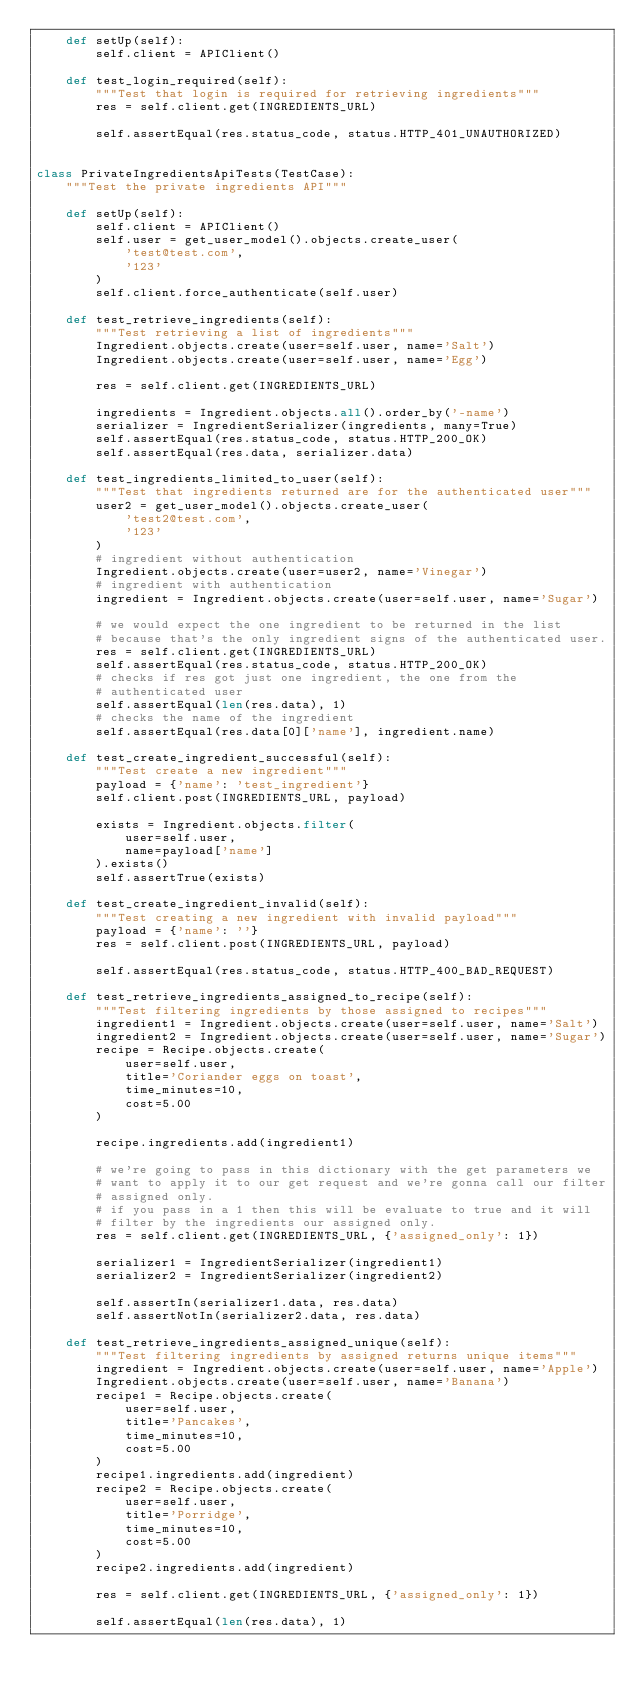<code> <loc_0><loc_0><loc_500><loc_500><_Python_>    def setUp(self):
        self.client = APIClient()

    def test_login_required(self):
        """Test that login is required for retrieving ingredients"""
        res = self.client.get(INGREDIENTS_URL)

        self.assertEqual(res.status_code, status.HTTP_401_UNAUTHORIZED)


class PrivateIngredientsApiTests(TestCase):
    """Test the private ingredients API"""

    def setUp(self):
        self.client = APIClient()
        self.user = get_user_model().objects.create_user(
            'test@test.com',
            '123'
        )
        self.client.force_authenticate(self.user)

    def test_retrieve_ingredients(self):
        """Test retrieving a list of ingredients"""
        Ingredient.objects.create(user=self.user, name='Salt')
        Ingredient.objects.create(user=self.user, name='Egg')

        res = self.client.get(INGREDIENTS_URL)

        ingredients = Ingredient.objects.all().order_by('-name')
        serializer = IngredientSerializer(ingredients, many=True)
        self.assertEqual(res.status_code, status.HTTP_200_OK)
        self.assertEqual(res.data, serializer.data)

    def test_ingredients_limited_to_user(self):
        """Test that ingredients returned are for the authenticated user"""
        user2 = get_user_model().objects.create_user(
            'test2@test.com',
            '123'
        )
        # ingredient without authentication
        Ingredient.objects.create(user=user2, name='Vinegar')
        # ingredient with authentication
        ingredient = Ingredient.objects.create(user=self.user, name='Sugar')

        # we would expect the one ingredient to be returned in the list
        # because that's the only ingredient signs of the authenticated user.
        res = self.client.get(INGREDIENTS_URL)
        self.assertEqual(res.status_code, status.HTTP_200_OK)
        # checks if res got just one ingredient, the one from the
        # authenticated user
        self.assertEqual(len(res.data), 1)
        # checks the name of the ingredient
        self.assertEqual(res.data[0]['name'], ingredient.name)

    def test_create_ingredient_successful(self):
        """Test create a new ingredient"""
        payload = {'name': 'test_ingredient'}
        self.client.post(INGREDIENTS_URL, payload)

        exists = Ingredient.objects.filter(
            user=self.user,
            name=payload['name']
        ).exists()
        self.assertTrue(exists)

    def test_create_ingredient_invalid(self):
        """Test creating a new ingredient with invalid payload"""
        payload = {'name': ''}
        res = self.client.post(INGREDIENTS_URL, payload)

        self.assertEqual(res.status_code, status.HTTP_400_BAD_REQUEST)

    def test_retrieve_ingredients_assigned_to_recipe(self):
        """Test filtering ingredients by those assigned to recipes"""
        ingredient1 = Ingredient.objects.create(user=self.user, name='Salt')
        ingredient2 = Ingredient.objects.create(user=self.user, name='Sugar')
        recipe = Recipe.objects.create(
            user=self.user,
            title='Coriander eggs on toast',
            time_minutes=10,
            cost=5.00
        )

        recipe.ingredients.add(ingredient1)

        # we're going to pass in this dictionary with the get parameters we
        # want to apply it to our get request and we're gonna call our filter
        # assigned only.
        # if you pass in a 1 then this will be evaluate to true and it will
        # filter by the ingredients our assigned only.
        res = self.client.get(INGREDIENTS_URL, {'assigned_only': 1})

        serializer1 = IngredientSerializer(ingredient1)
        serializer2 = IngredientSerializer(ingredient2)

        self.assertIn(serializer1.data, res.data)
        self.assertNotIn(serializer2.data, res.data)

    def test_retrieve_ingredients_assigned_unique(self):
        """Test filtering ingredients by assigned returns unique items"""
        ingredient = Ingredient.objects.create(user=self.user, name='Apple')
        Ingredient.objects.create(user=self.user, name='Banana')
        recipe1 = Recipe.objects.create(
            user=self.user,
            title='Pancakes',
            time_minutes=10,
            cost=5.00
        )
        recipe1.ingredients.add(ingredient)
        recipe2 = Recipe.objects.create(
            user=self.user,
            title='Porridge',
            time_minutes=10,
            cost=5.00
        )
        recipe2.ingredients.add(ingredient)

        res = self.client.get(INGREDIENTS_URL, {'assigned_only': 1})

        self.assertEqual(len(res.data), 1)
</code> 